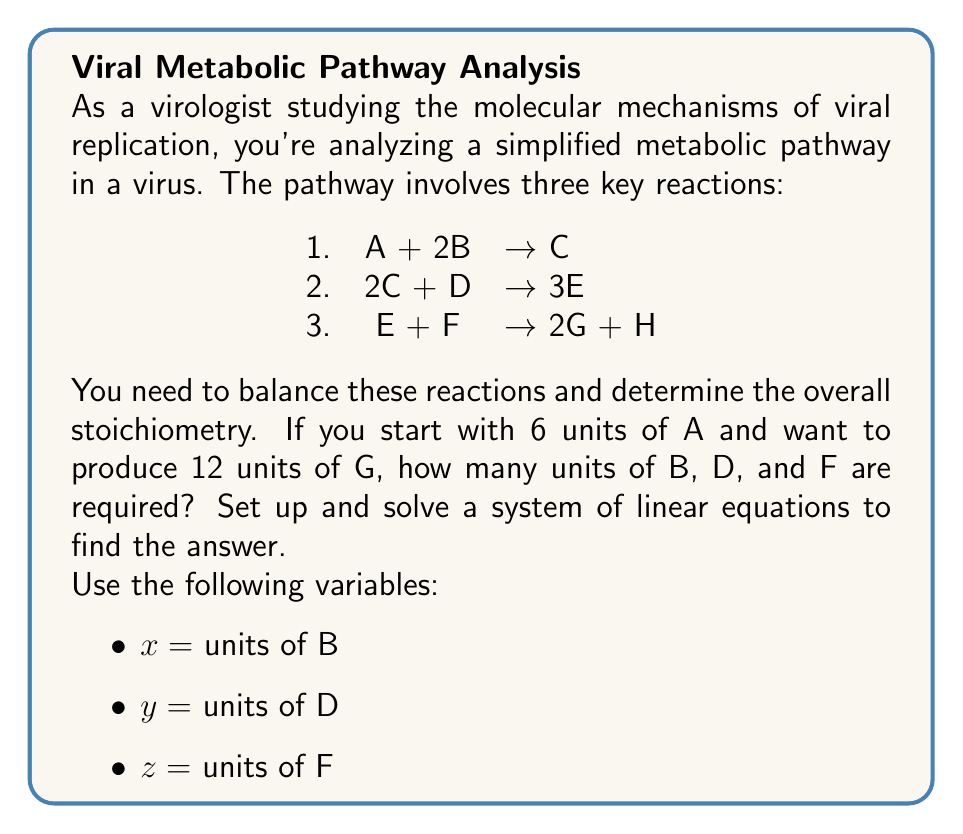Teach me how to tackle this problem. Let's approach this step-by-step:

1) First, we need to set up equations based on the given reactions and the desired output:

   Reaction 1: 6A + 2x B → 6C  (we start with 6 units of A)
   Reaction 2: 12C + y D → 18E (we need 18E to produce 12G)
   Reaction 3: 18E + z F → 12G + 6H (we want 12G)

2) Now, we can set up a system of linear equations:

   $$\begin{cases}
   2x = 6 \\
   12 + y = 18 \\
   18 + z = 18
   \end{cases}$$

3) Solving these equations:

   From equation 1: $x = 3$
   From equation 2: $y = 6$
   From equation 3: $z = 0$

4) Let's verify the balance:

   6A + 6B → 6C
   12C + 6D → 18E
   18E + 0F → 12G + 6H

   The reactions are balanced and produce the desired 12 units of G.
Answer: 3 units of B, 6 units of D, 0 units of F 